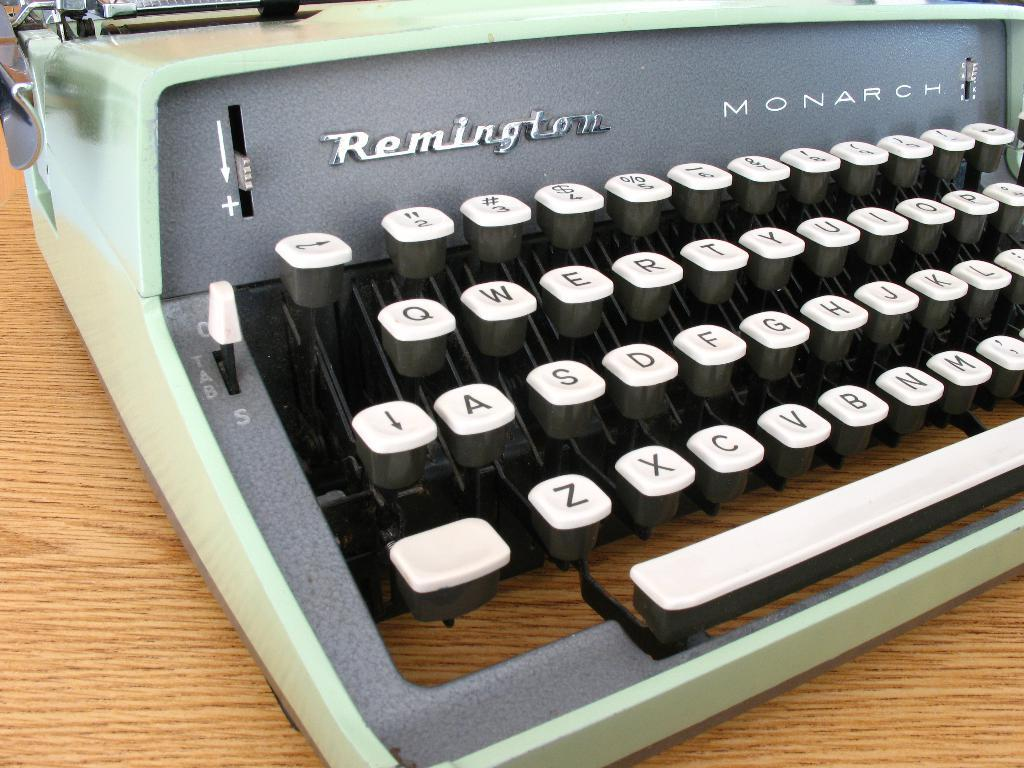Provide a one-sentence caption for the provided image. An old typewriter called the Remington Monarch sits on a wood table. 